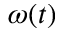Convert formula to latex. <formula><loc_0><loc_0><loc_500><loc_500>\omega ( t )</formula> 